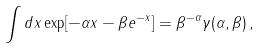Convert formula to latex. <formula><loc_0><loc_0><loc_500><loc_500>\int d x \exp [ - \alpha x - \beta e ^ { - x } ] = \beta ^ { - \alpha } \gamma ( \alpha , \beta ) \, ,</formula> 